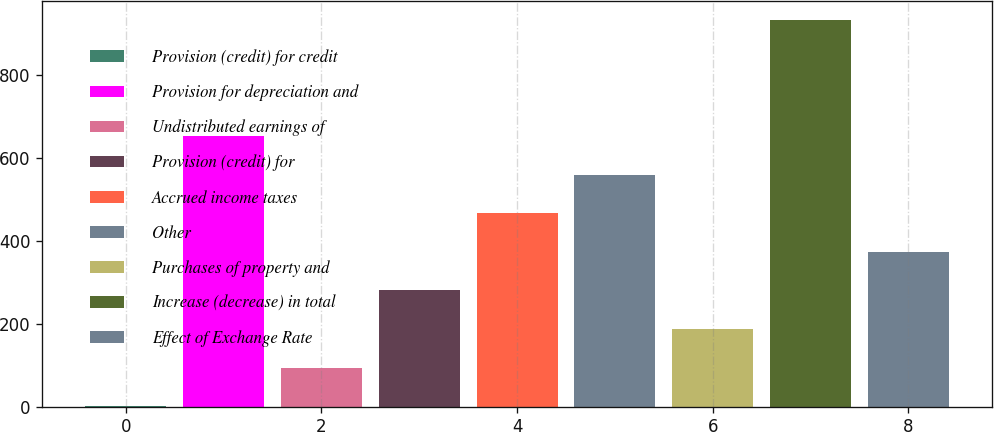<chart> <loc_0><loc_0><loc_500><loc_500><bar_chart><fcel>Provision (credit) for credit<fcel>Provision for depreciation and<fcel>Undistributed earnings of<fcel>Provision (credit) for<fcel>Accrued income taxes<fcel>Other<fcel>Purchases of property and<fcel>Increase (decrease) in total<fcel>Effect of Exchange Rate<nl><fcel>0.9<fcel>652.18<fcel>93.94<fcel>280.02<fcel>466.1<fcel>559.14<fcel>186.98<fcel>931.3<fcel>373.06<nl></chart> 